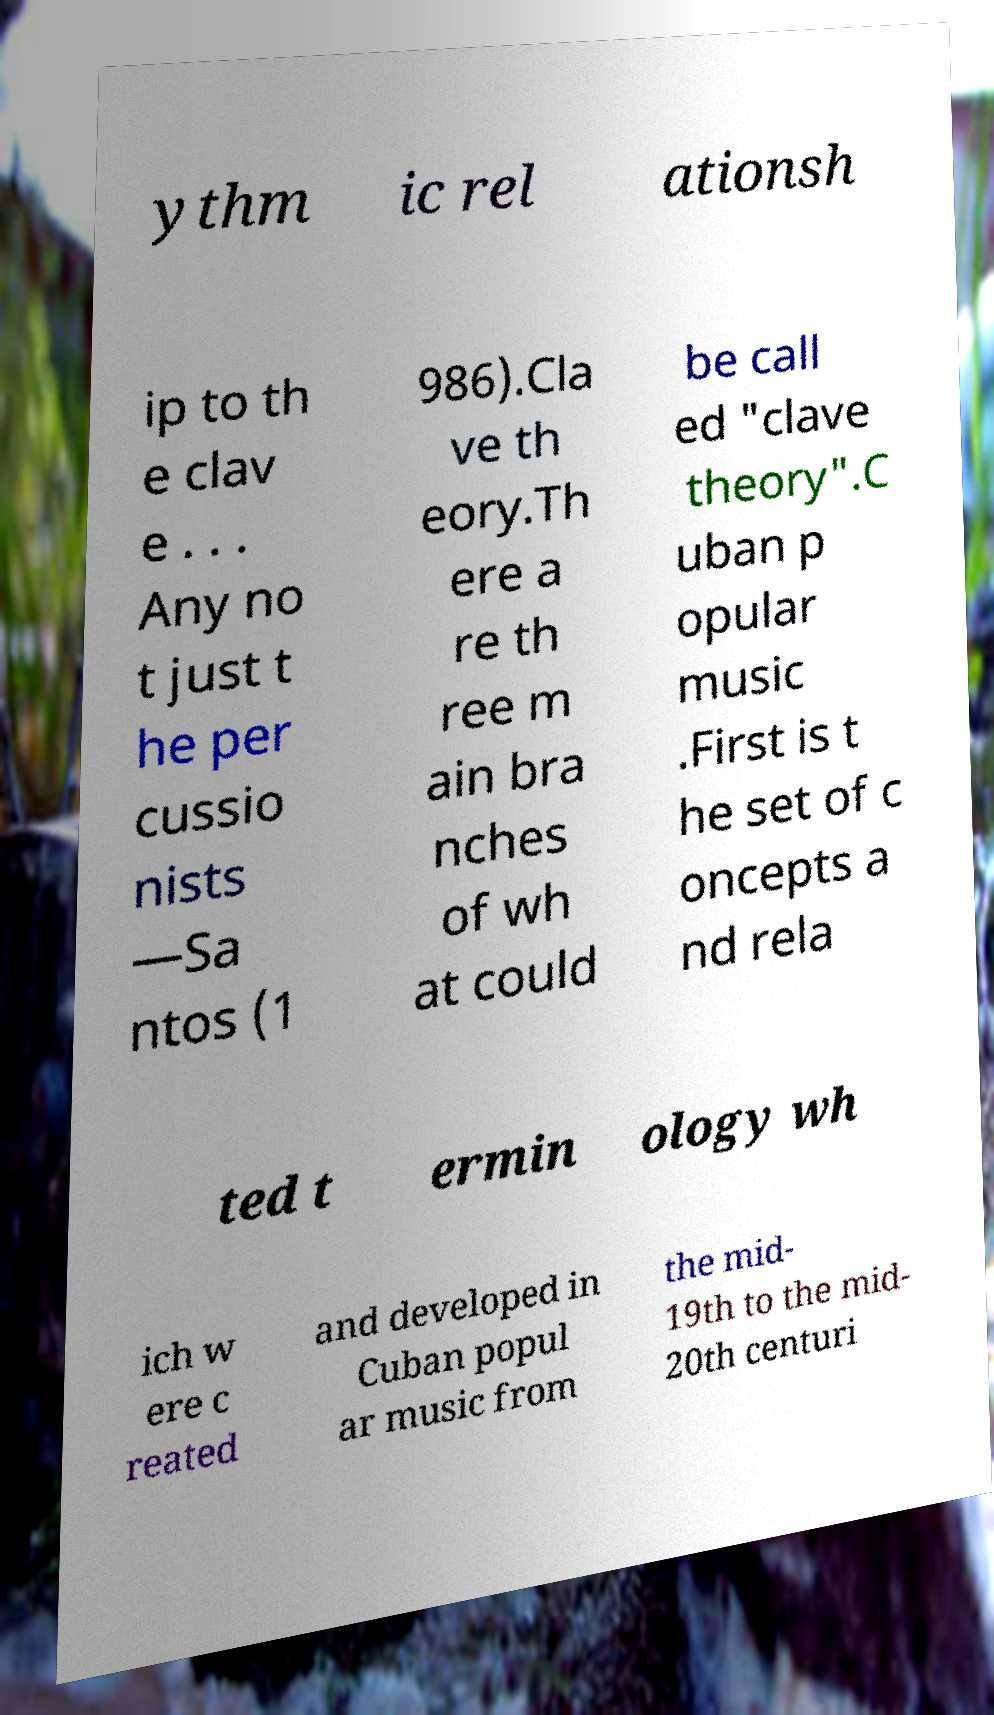There's text embedded in this image that I need extracted. Can you transcribe it verbatim? ythm ic rel ationsh ip to th e clav e . . . Any no t just t he per cussio nists —Sa ntos (1 986).Cla ve th eory.Th ere a re th ree m ain bra nches of wh at could be call ed "clave theory".C uban p opular music .First is t he set of c oncepts a nd rela ted t ermin ology wh ich w ere c reated and developed in Cuban popul ar music from the mid- 19th to the mid- 20th centuri 